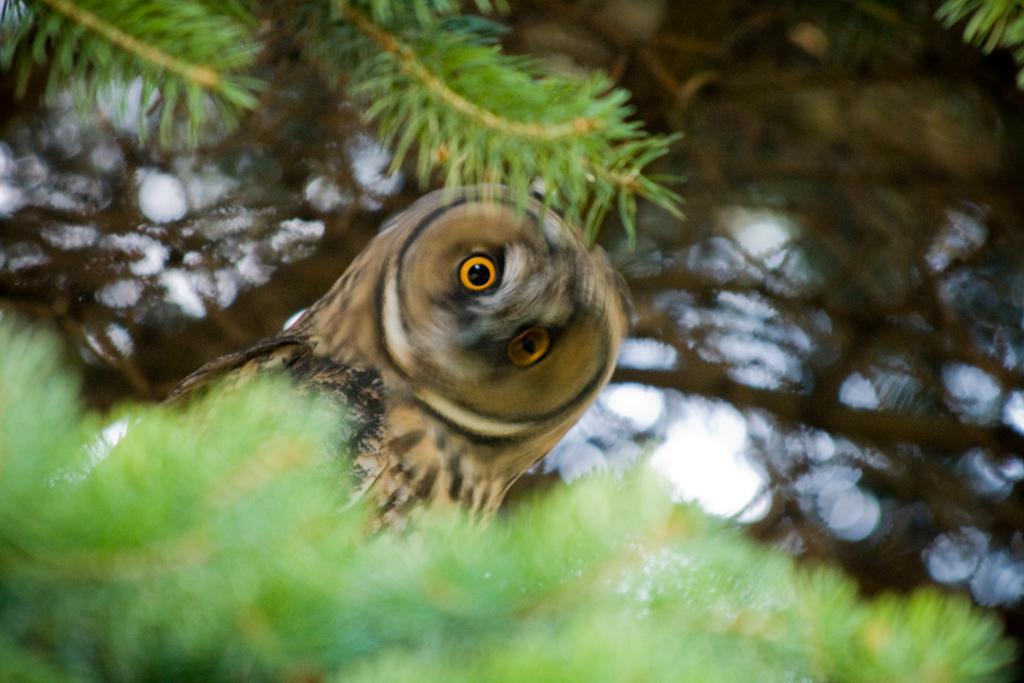Describe this image in one or two sentences. In this image I can see an owl. Also there are leaves and there is a blur background. 